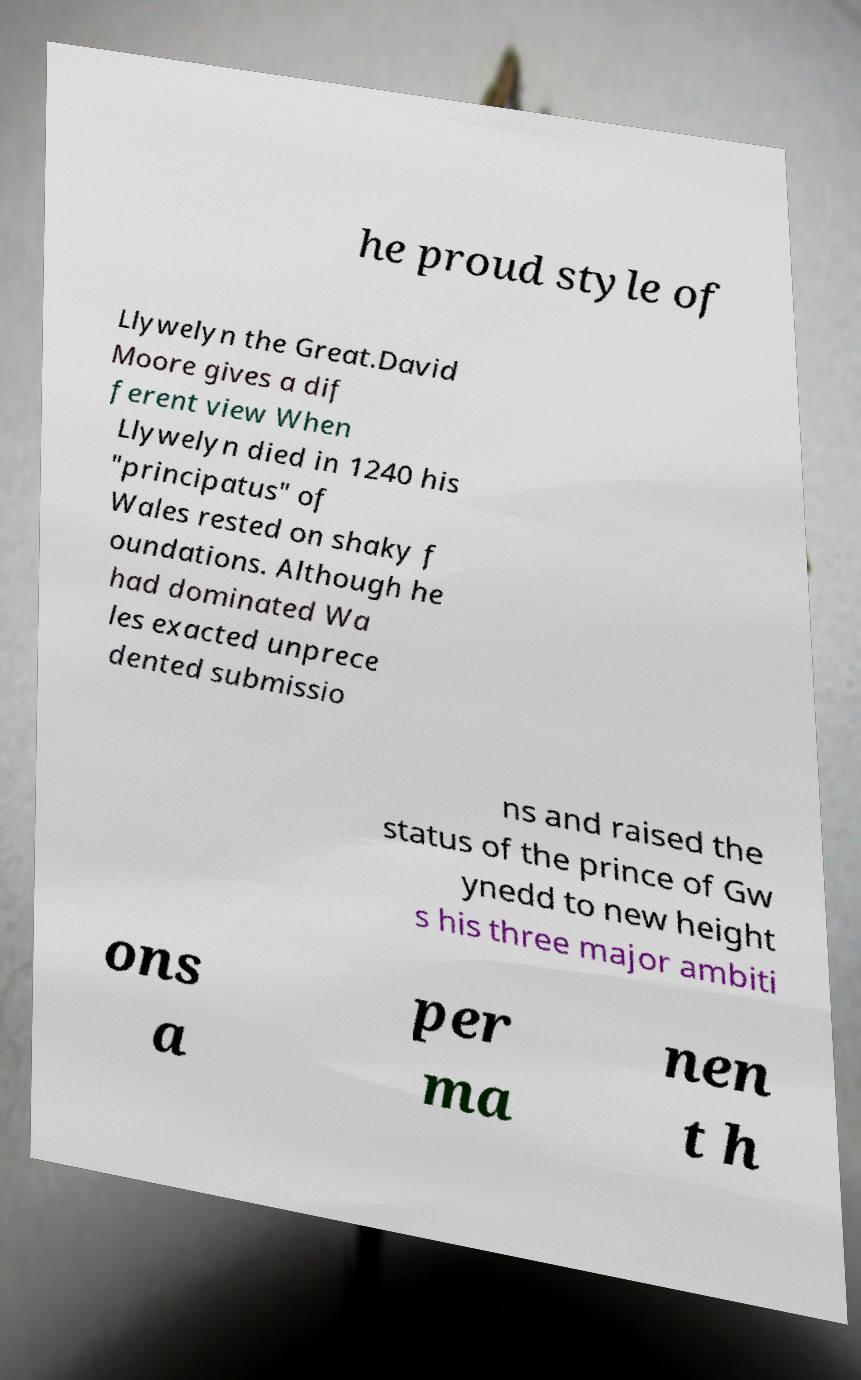Please identify and transcribe the text found in this image. he proud style of Llywelyn the Great.David Moore gives a dif ferent view When Llywelyn died in 1240 his "principatus" of Wales rested on shaky f oundations. Although he had dominated Wa les exacted unprece dented submissio ns and raised the status of the prince of Gw ynedd to new height s his three major ambiti ons a per ma nen t h 